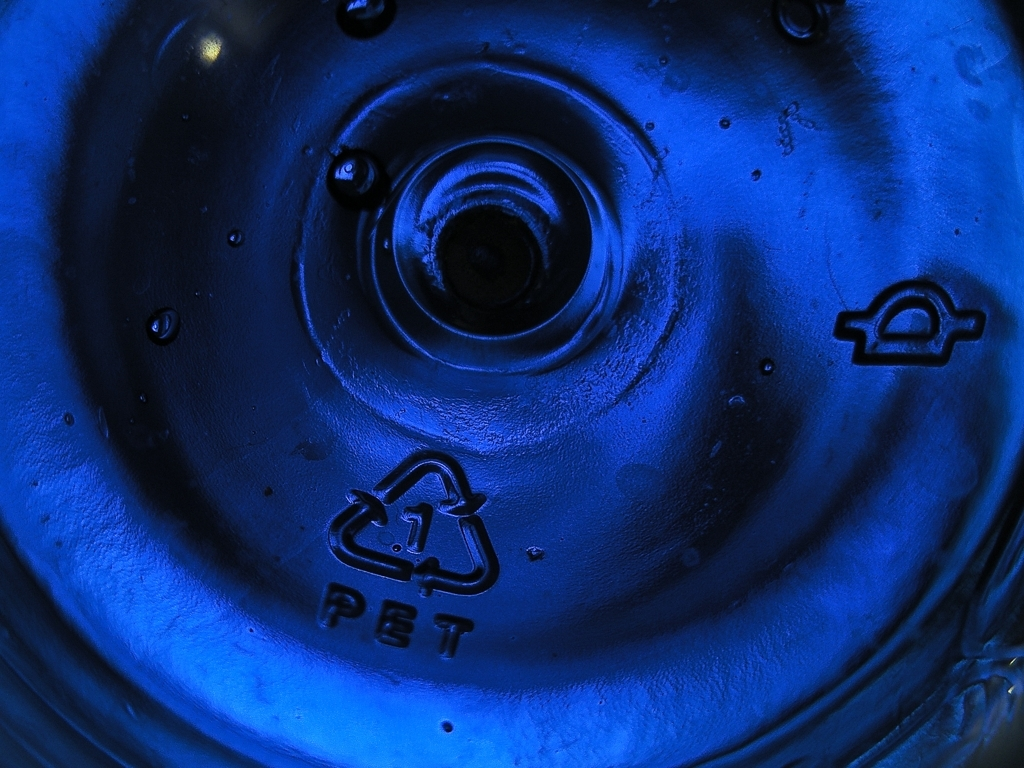Describe the lighting and shadow effects seen in the image. The lighting in the image casts a concentrated, glowing center, creating shadows that radiate outward and accentuate the circular grooves of the object. This effect gives the image a dynamic and somewhat dramatic appearance, highlighting textures and the three-dimensional form of the object. 